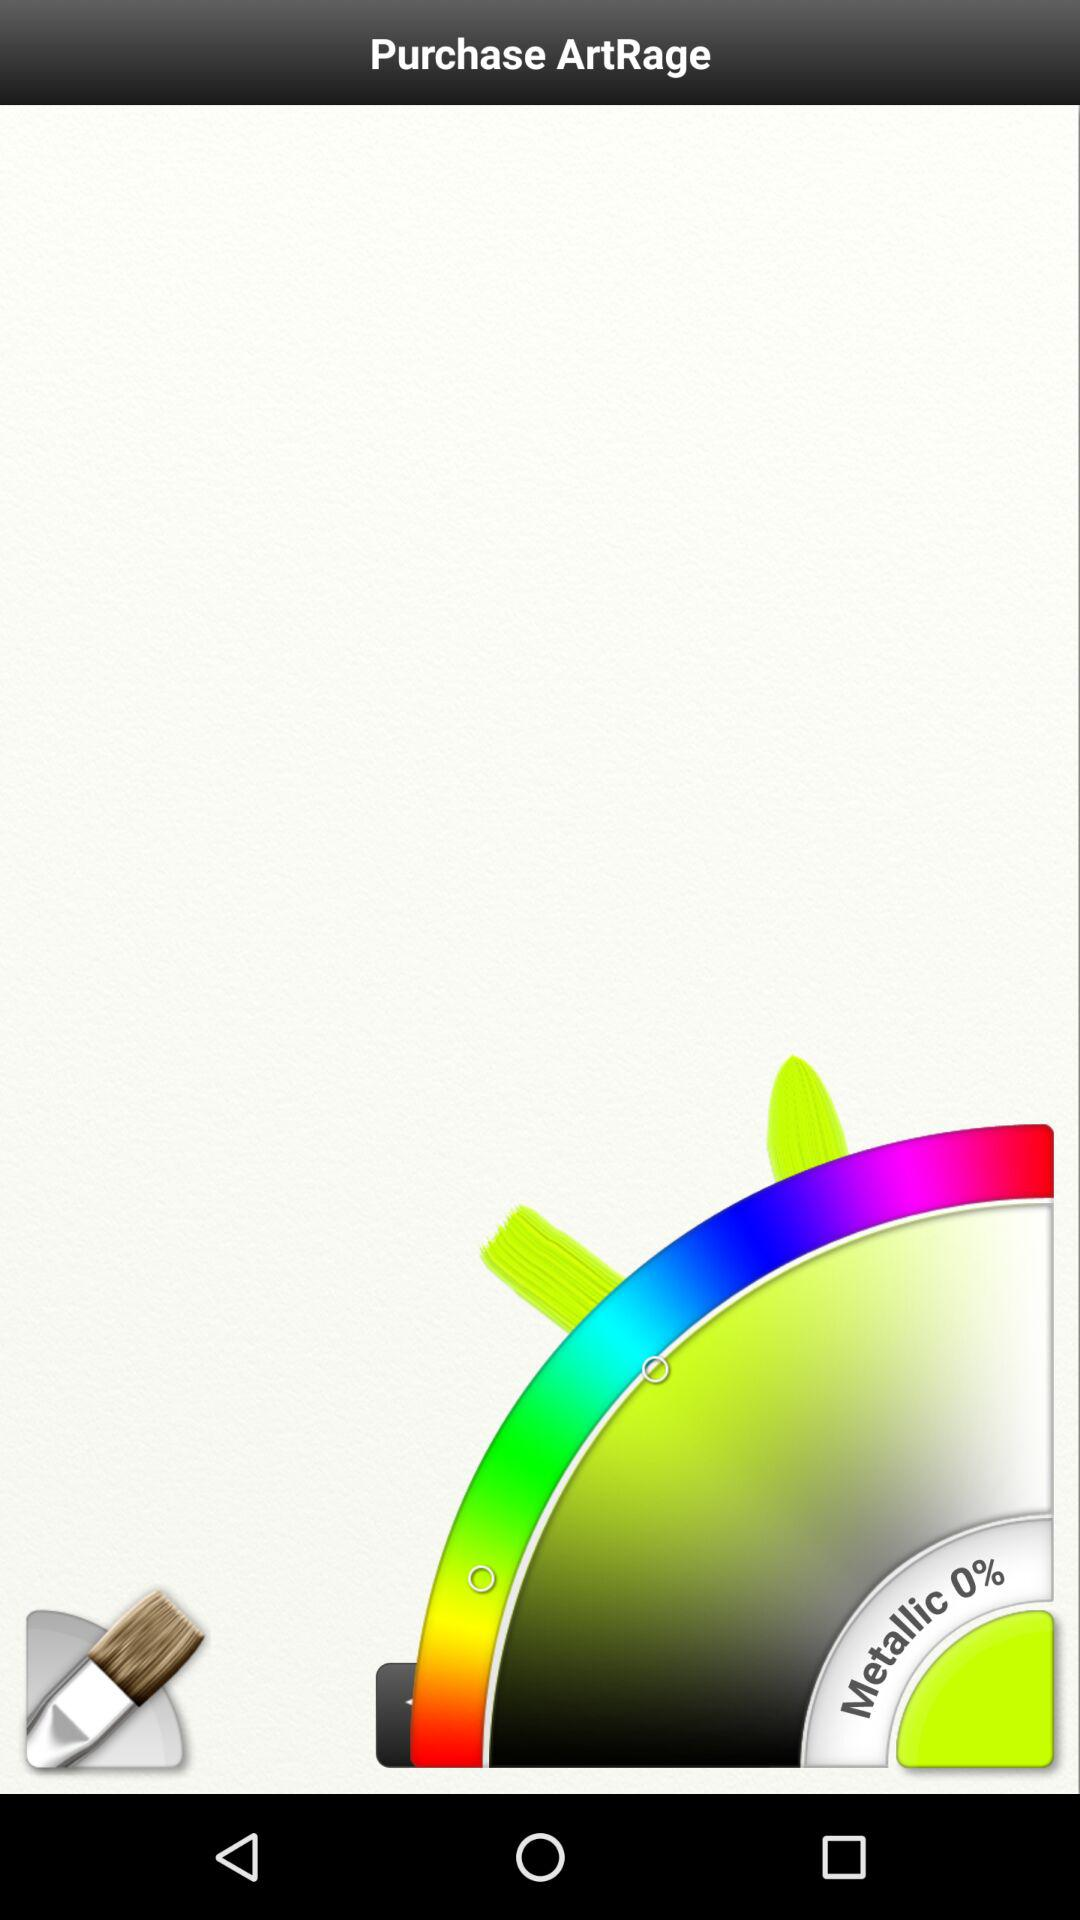What is the metallic percentage? The metallic percentage is 0. 